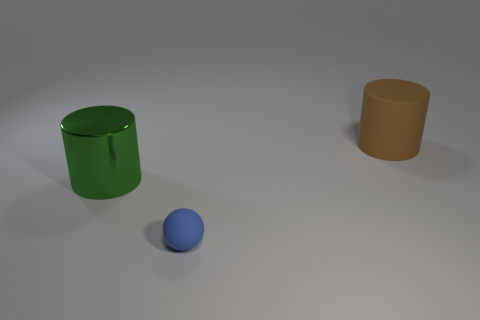What kind of surface are the objects placed on? They are positioned on a smooth, matte surface that appears to be a subtle grey, which suggests an unobstructed background typically used in product photography or 3D modelling scenes. 